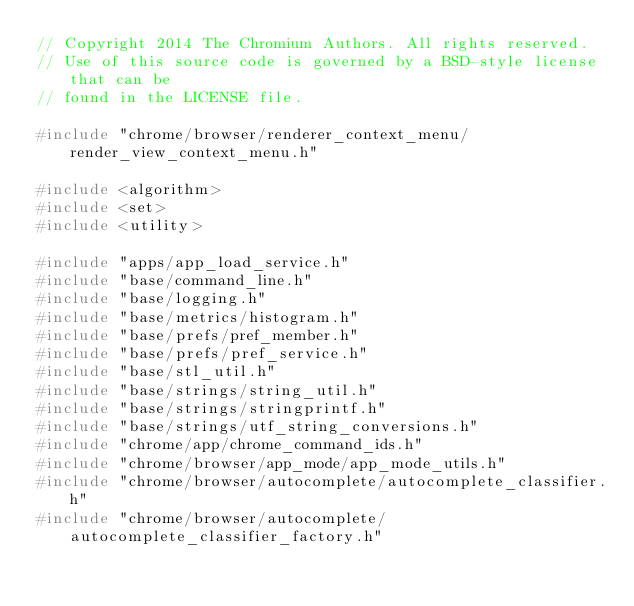<code> <loc_0><loc_0><loc_500><loc_500><_C++_>// Copyright 2014 The Chromium Authors. All rights reserved.
// Use of this source code is governed by a BSD-style license that can be
// found in the LICENSE file.

#include "chrome/browser/renderer_context_menu/render_view_context_menu.h"

#include <algorithm>
#include <set>
#include <utility>

#include "apps/app_load_service.h"
#include "base/command_line.h"
#include "base/logging.h"
#include "base/metrics/histogram.h"
#include "base/prefs/pref_member.h"
#include "base/prefs/pref_service.h"
#include "base/stl_util.h"
#include "base/strings/string_util.h"
#include "base/strings/stringprintf.h"
#include "base/strings/utf_string_conversions.h"
#include "chrome/app/chrome_command_ids.h"
#include "chrome/browser/app_mode/app_mode_utils.h"
#include "chrome/browser/autocomplete/autocomplete_classifier.h"
#include "chrome/browser/autocomplete/autocomplete_classifier_factory.h"</code> 